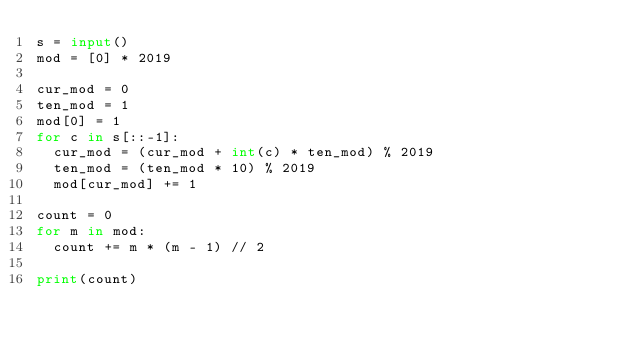<code> <loc_0><loc_0><loc_500><loc_500><_Python_>s = input()
mod = [0] * 2019

cur_mod = 0
ten_mod = 1
mod[0] = 1
for c in s[::-1]:
  cur_mod = (cur_mod + int(c) * ten_mod) % 2019
  ten_mod = (ten_mod * 10) % 2019
  mod[cur_mod] += 1

count = 0
for m in mod:
  count += m * (m - 1) // 2

print(count)</code> 